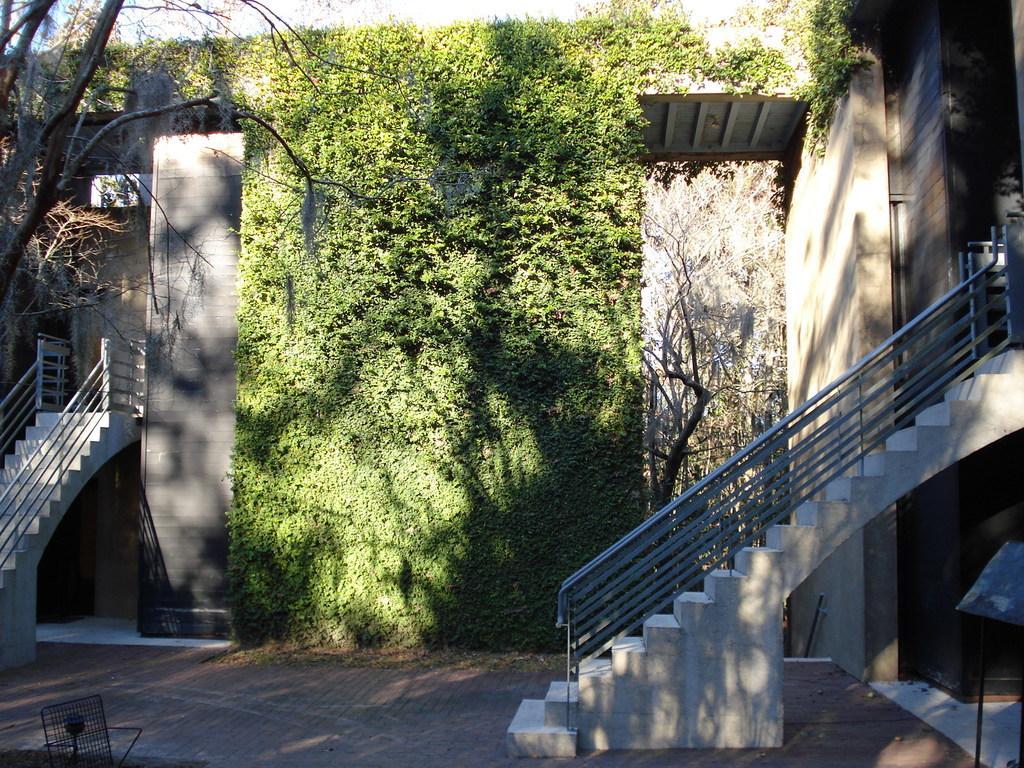In one or two sentences, can you explain what this image depicts? In this picture we can see the buildings, stairs, railing, dry trees, plants and roof. At the bottom of the image we can see the floor. At the top of the image we can see the sky. 